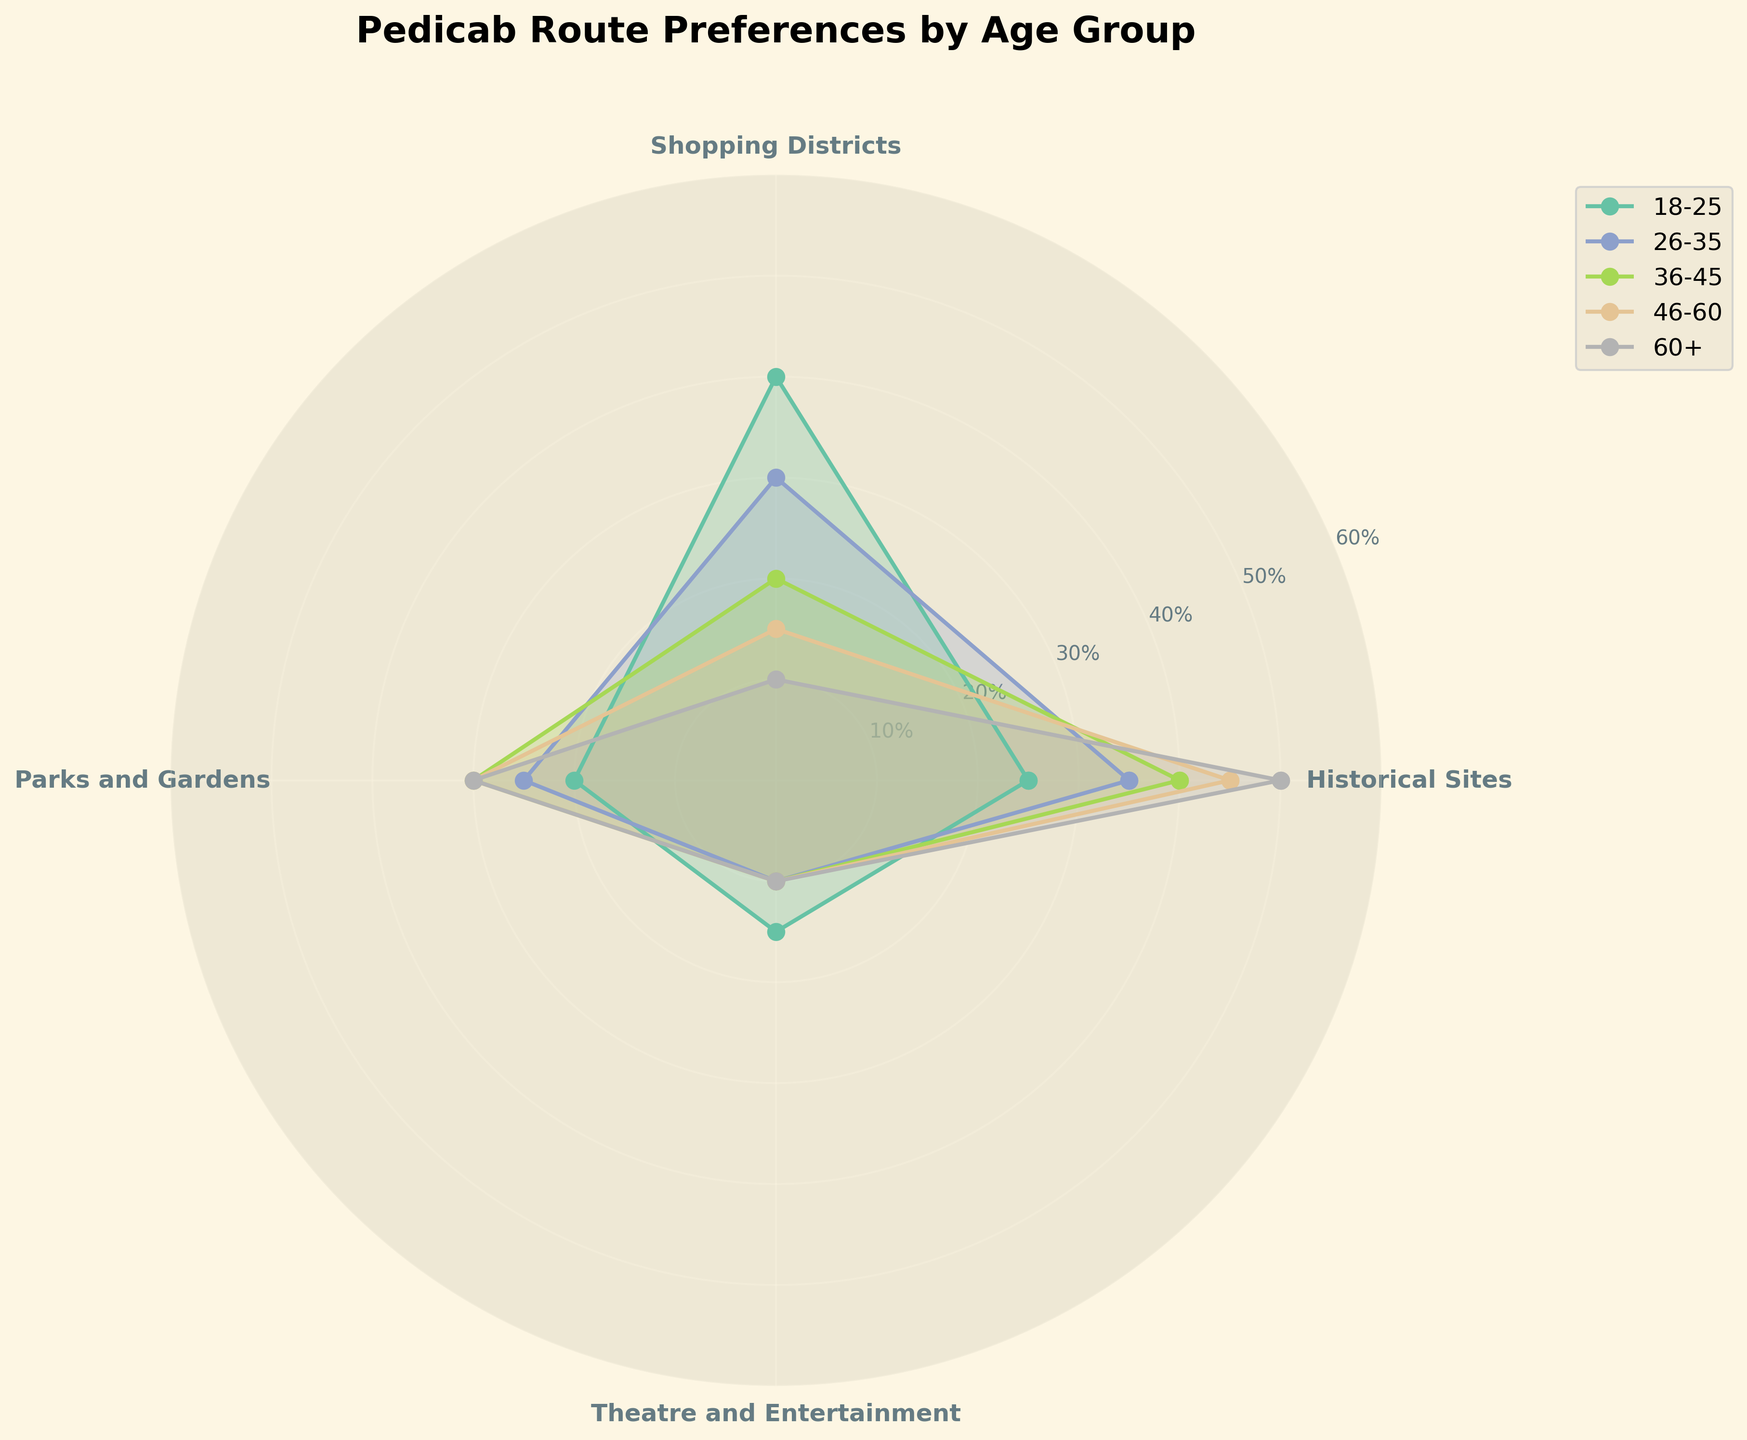What's the title of the figure? The title is positioned at the top of the figure.
Answer: Pedicab Route Preferences by Age Group What age group prefers Historical Sites the most? Identify the age group with the highest percentage for Historical Sites by observing the radial distances. The segment for the age group 60+ extends furthest for Historical Sites.
Answer: 60+ Which route type is least preferred by the 18-25 age group? Compare the radial distances for all route types within the 18-25 age group. The segment for Theatre and Entertainment has the shortest radial distance.
Answer: Theatre and Entertainment What is the sum of preferences for the Shopping Districts route type across all age groups? Sum the percentages listed for Shopping Districts across all age groups: 40% (18-25) + 30% (26-35) + 20% (36-45) + 15% (46-60) + 10% (60+). This equals 115%.
Answer: 115% Which age group has the smallest range of preference percentages across all route types? Calculate the range (maximum percent minus minimum percent) for each age group. Find the group with the smallest range by visual inspection or calculation. For 26-35, the range is 35%-10%=25%. For other groups: 25%-15% (18-25)=25%, 40%-10% (36-45)=30%, 45%-10% (46-60)=35%, 50%-10% (60+)=40%. So, groups 18-25 and 26-35 both have the smallest range, which is 30%.
Answer: 18-25 and 26-35 How does the preference for Parks and Gardens change with age? Trace the percentage values for Parks and Gardens as age groups increase: 20% (18-25), 25% (26-35), 30% (36-45), 30% (46-60), 30% (60+). The preference increases from 18-25 to 36-45 and then remains the same.
Answer: Increases then remains same Which route type shows the most consistent preference across all age groups? By visual inspection, determine which route type shows the smallest variation in radial distances across age groups. Theatre and Entertainment has percentages of 15%, 10%, 10%, 10%, and 10%, showing little variation.
Answer: Theatre and Entertainment Compare the preferences for Historical Sites between the 36-45 and 46-60 age groups. Find the percentages for Historical Sites: 36-45 (40%) and 46-60 (45%). Notice that the 46-60 age group has a higher percentage.
Answer: 46-60 prefers more Which age group has the highest preference for Shopping Districts? Identify the age group with the longest radial segment for Shopping Districts. The age group 18-25 has the highest percentage (40%).
Answer: 18-25 